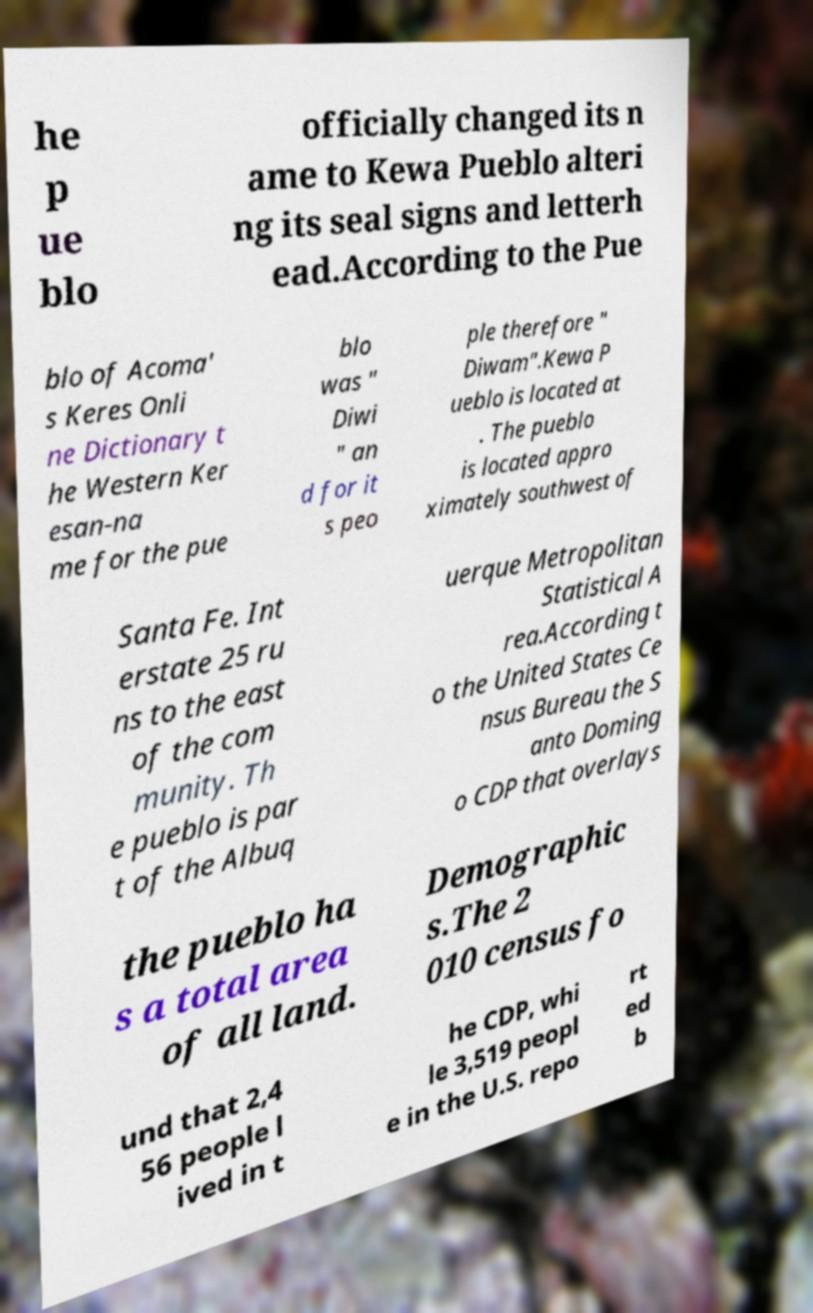I need the written content from this picture converted into text. Can you do that? he p ue blo officially changed its n ame to Kewa Pueblo alteri ng its seal signs and letterh ead.According to the Pue blo of Acoma' s Keres Onli ne Dictionary t he Western Ker esan-na me for the pue blo was " Diwi " an d for it s peo ple therefore " Diwam".Kewa P ueblo is located at . The pueblo is located appro ximately southwest of Santa Fe. Int erstate 25 ru ns to the east of the com munity. Th e pueblo is par t of the Albuq uerque Metropolitan Statistical A rea.According t o the United States Ce nsus Bureau the S anto Doming o CDP that overlays the pueblo ha s a total area of all land. Demographic s.The 2 010 census fo und that 2,4 56 people l ived in t he CDP, whi le 3,519 peopl e in the U.S. repo rt ed b 